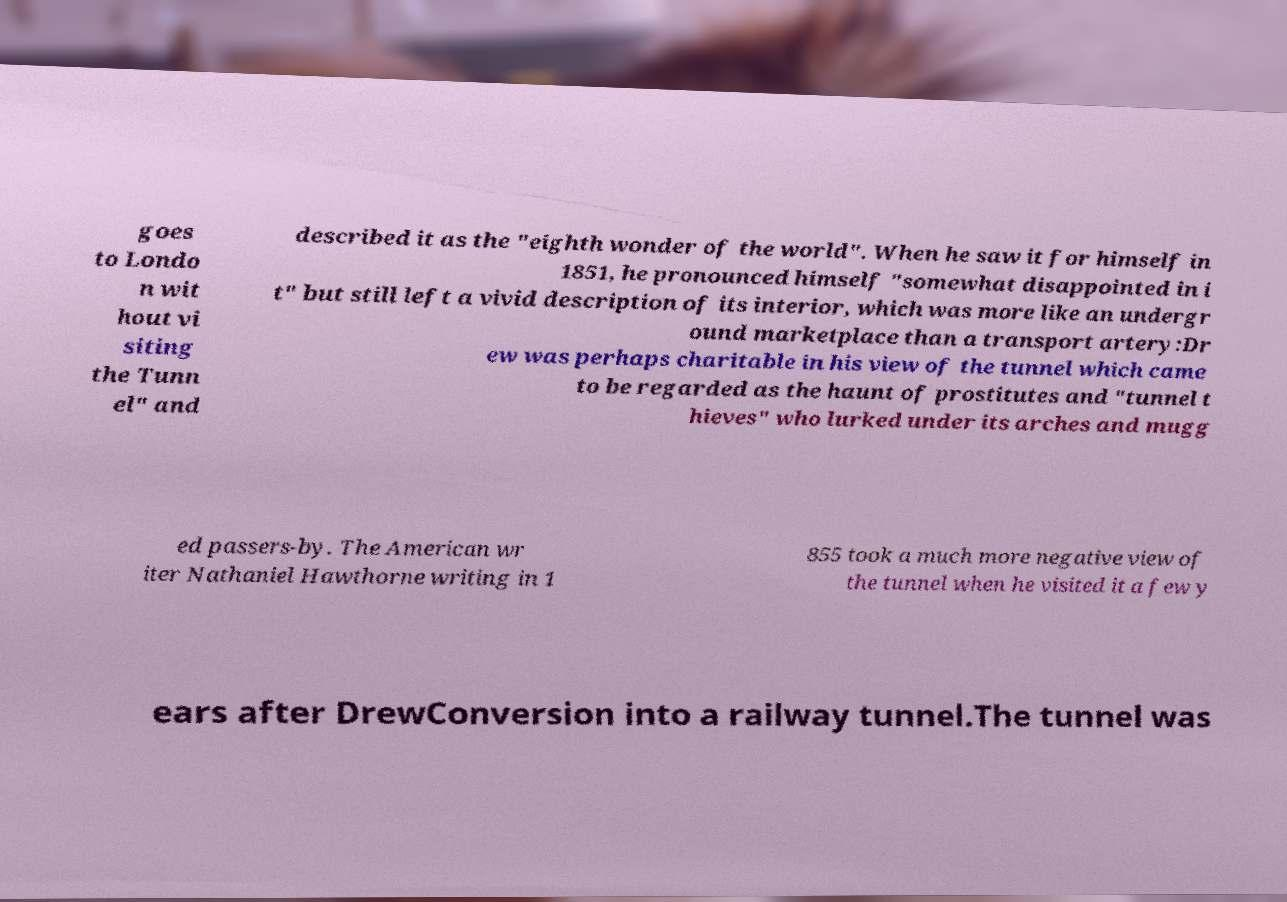I need the written content from this picture converted into text. Can you do that? goes to Londo n wit hout vi siting the Tunn el" and described it as the "eighth wonder of the world". When he saw it for himself in 1851, he pronounced himself "somewhat disappointed in i t" but still left a vivid description of its interior, which was more like an undergr ound marketplace than a transport artery:Dr ew was perhaps charitable in his view of the tunnel which came to be regarded as the haunt of prostitutes and "tunnel t hieves" who lurked under its arches and mugg ed passers-by. The American wr iter Nathaniel Hawthorne writing in 1 855 took a much more negative view of the tunnel when he visited it a few y ears after DrewConversion into a railway tunnel.The tunnel was 